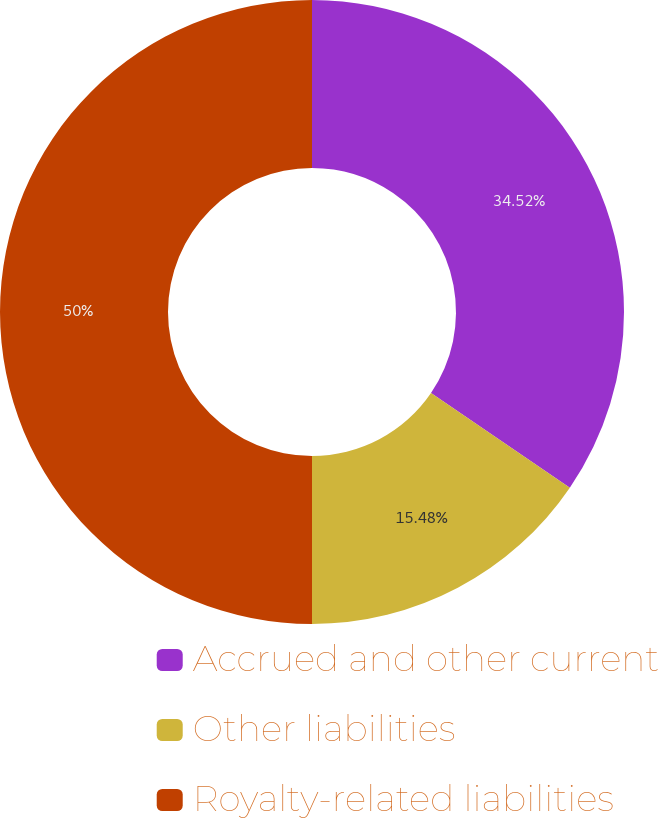<chart> <loc_0><loc_0><loc_500><loc_500><pie_chart><fcel>Accrued and other current<fcel>Other liabilities<fcel>Royalty-related liabilities<nl><fcel>34.52%<fcel>15.48%<fcel>50.0%<nl></chart> 